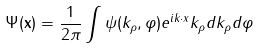Convert formula to latex. <formula><loc_0><loc_0><loc_500><loc_500>\Psi ( \mathbf x ) = \frac { 1 } { 2 \pi } \int \psi ( k _ { \rho } , \varphi ) e ^ { i k \cdot x } k _ { \rho } d k _ { \rho } d \varphi</formula> 